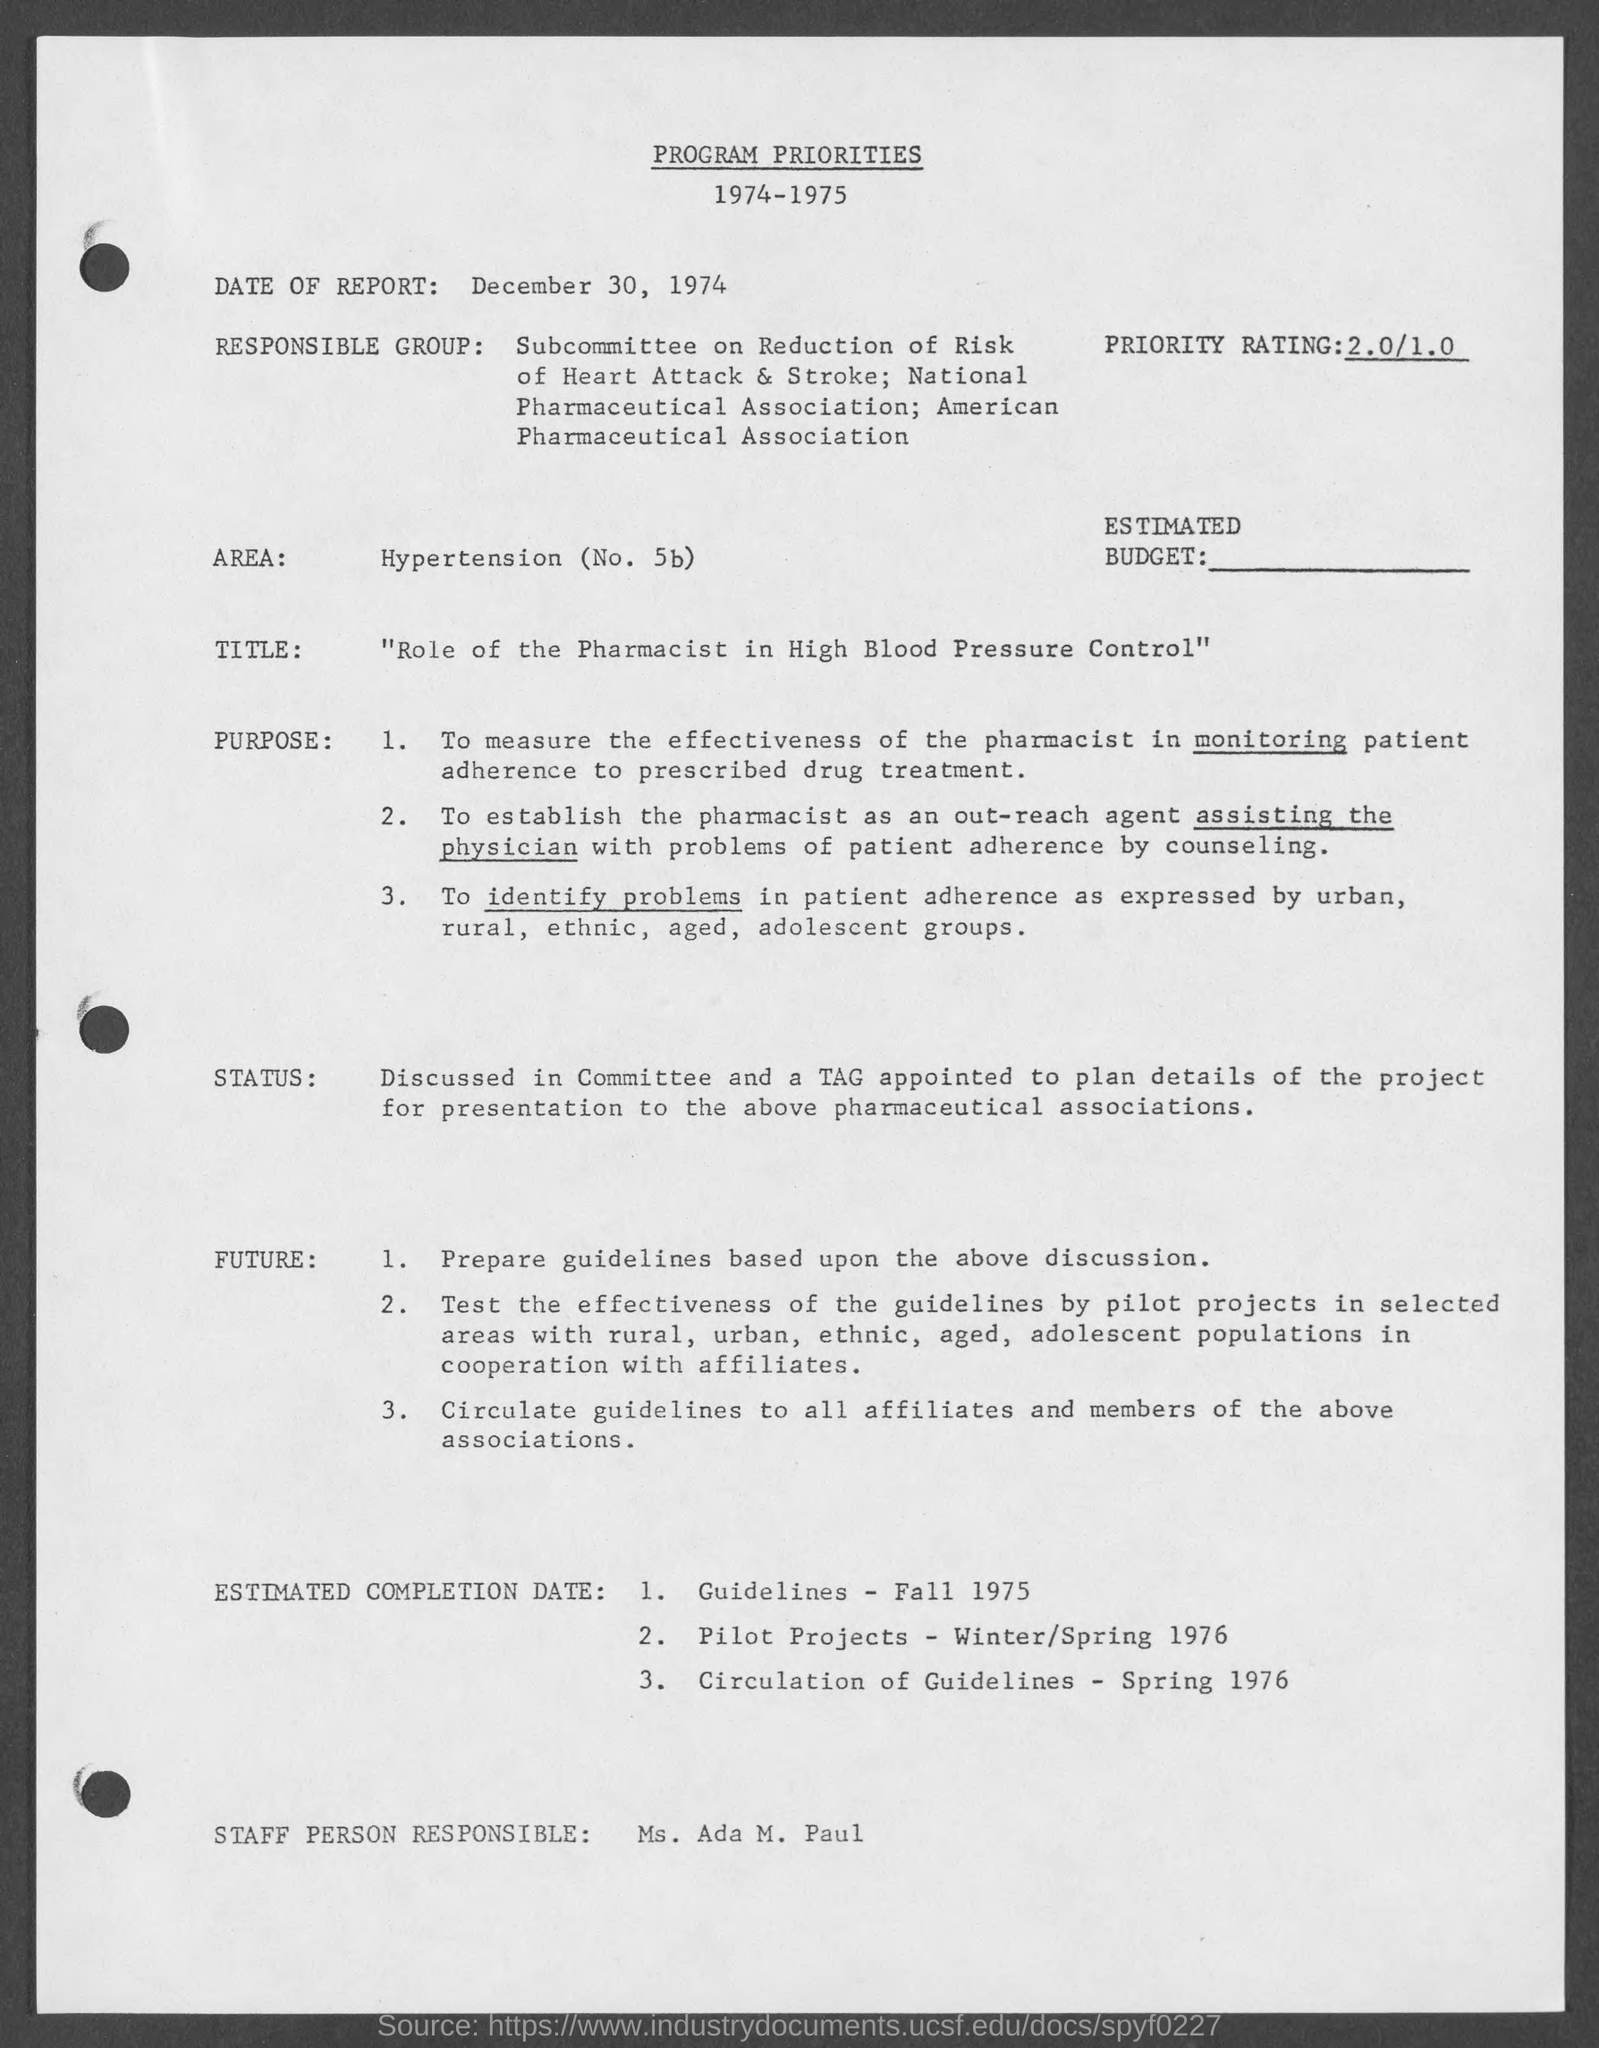What is the date of report ?
Your answer should be compact. December 30, 1974. Who is the staff person responsible?
Your answer should be very brief. Ms. ada M. Paul. What is the estimated completion date for guidelines ?
Ensure brevity in your answer.  Fall 1975. What is the estimated completion date for circulation of guidelines ?
Your answer should be very brief. Spring 1976. 